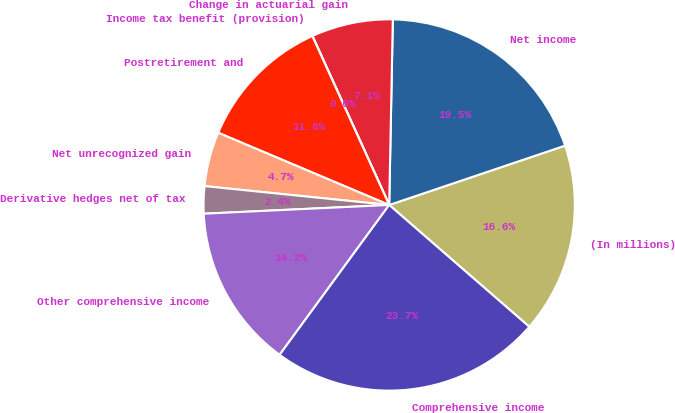Convert chart to OTSL. <chart><loc_0><loc_0><loc_500><loc_500><pie_chart><fcel>(In millions)<fcel>Net income<fcel>Change in actuarial gain<fcel>Income tax benefit (provision)<fcel>Postretirement and<fcel>Net unrecognized gain<fcel>Derivative hedges net of tax<fcel>Other comprehensive income<fcel>Comprehensive income<nl><fcel>16.57%<fcel>19.51%<fcel>7.1%<fcel>0.01%<fcel>11.84%<fcel>4.74%<fcel>2.37%<fcel>14.2%<fcel>23.66%<nl></chart> 